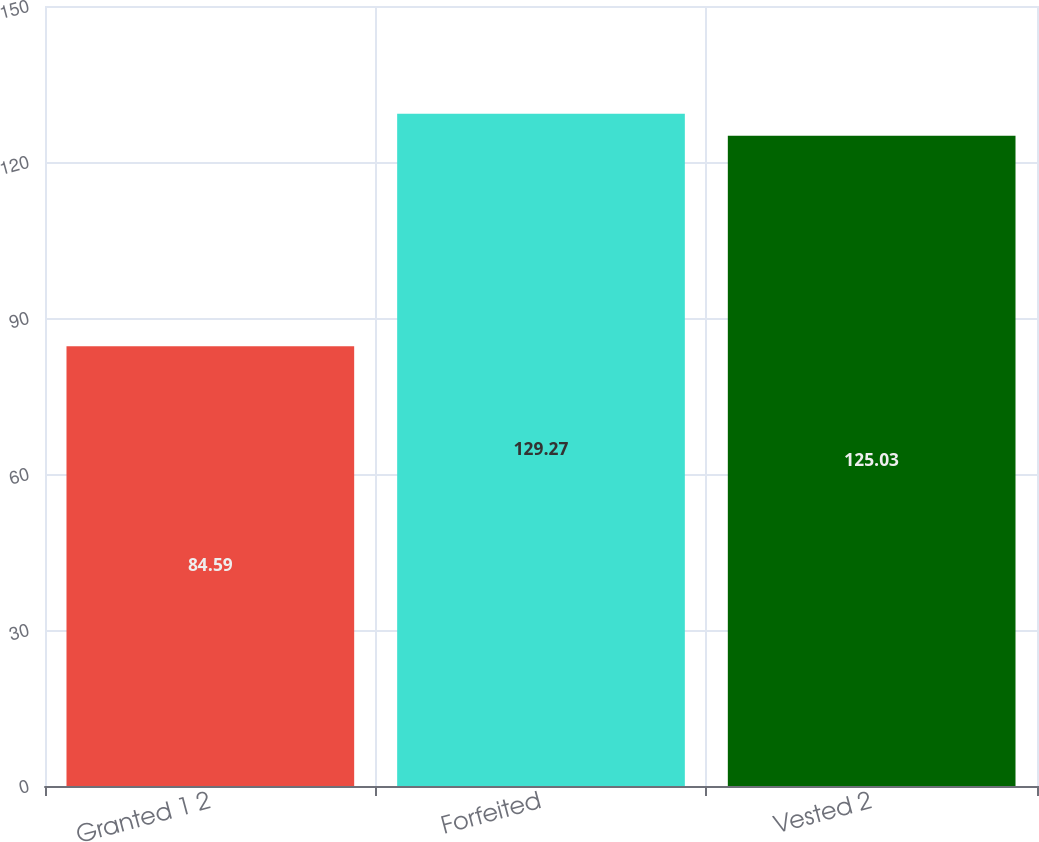Convert chart. <chart><loc_0><loc_0><loc_500><loc_500><bar_chart><fcel>Granted 1 2<fcel>Forfeited<fcel>Vested 2<nl><fcel>84.59<fcel>129.27<fcel>125.03<nl></chart> 